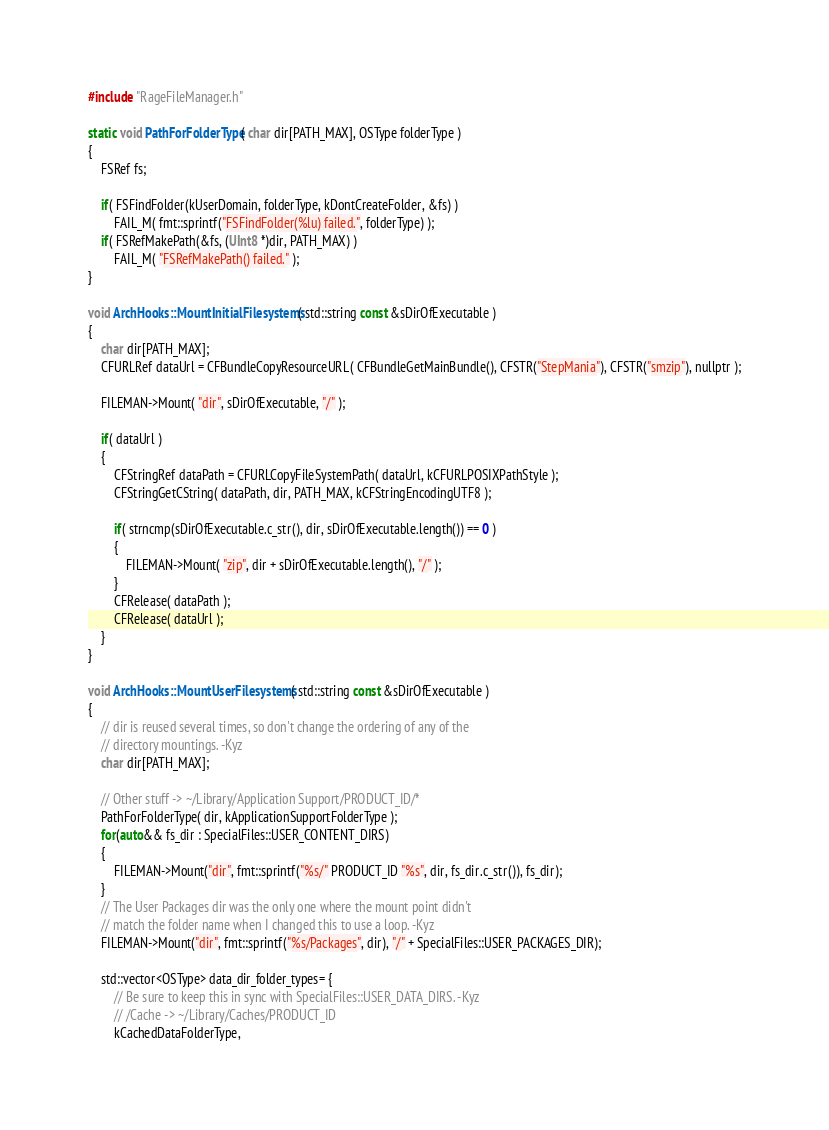Convert code to text. <code><loc_0><loc_0><loc_500><loc_500><_ObjectiveC_>
#include "RageFileManager.h"

static void PathForFolderType( char dir[PATH_MAX], OSType folderType )
{
	FSRef fs;

	if( FSFindFolder(kUserDomain, folderType, kDontCreateFolder, &fs) )
		FAIL_M( fmt::sprintf("FSFindFolder(%lu) failed.", folderType) );
	if( FSRefMakePath(&fs, (UInt8 *)dir, PATH_MAX) )
		FAIL_M( "FSRefMakePath() failed." );
}

void ArchHooks::MountInitialFilesystems( std::string const &sDirOfExecutable )
{
	char dir[PATH_MAX];
	CFURLRef dataUrl = CFBundleCopyResourceURL( CFBundleGetMainBundle(), CFSTR("StepMania"), CFSTR("smzip"), nullptr );

	FILEMAN->Mount( "dir", sDirOfExecutable, "/" );

	if( dataUrl )
	{
		CFStringRef dataPath = CFURLCopyFileSystemPath( dataUrl, kCFURLPOSIXPathStyle );
		CFStringGetCString( dataPath, dir, PATH_MAX, kCFStringEncodingUTF8 );

		if( strncmp(sDirOfExecutable.c_str(), dir, sDirOfExecutable.length()) == 0 )
		{
			FILEMAN->Mount( "zip", dir + sDirOfExecutable.length(), "/" );
		}
		CFRelease( dataPath );
		CFRelease( dataUrl );
	}
}

void ArchHooks::MountUserFilesystems( std::string const &sDirOfExecutable )
{
	// dir is reused several times, so don't change the ordering of any of the
	// directory mountings. -Kyz
	char dir[PATH_MAX];

	// Other stuff -> ~/Library/Application Support/PRODUCT_ID/*
	PathForFolderType( dir, kApplicationSupportFolderType );
	for(auto&& fs_dir : SpecialFiles::USER_CONTENT_DIRS)
	{
		FILEMAN->Mount("dir", fmt::sprintf("%s/" PRODUCT_ID "%s", dir, fs_dir.c_str()), fs_dir);
	}
	// The User Packages dir was the only one where the mount point didn't
	// match the folder name when I changed this to use a loop. -Kyz
	FILEMAN->Mount("dir", fmt::sprintf("%s/Packages", dir), "/" + SpecialFiles::USER_PACKAGES_DIR);

	std::vector<OSType> data_dir_folder_types= {
		// Be sure to keep this in sync with SpecialFiles::USER_DATA_DIRS. -Kyz
		// /Cache -> ~/Library/Caches/PRODUCT_ID
		kCachedDataFolderType,</code> 